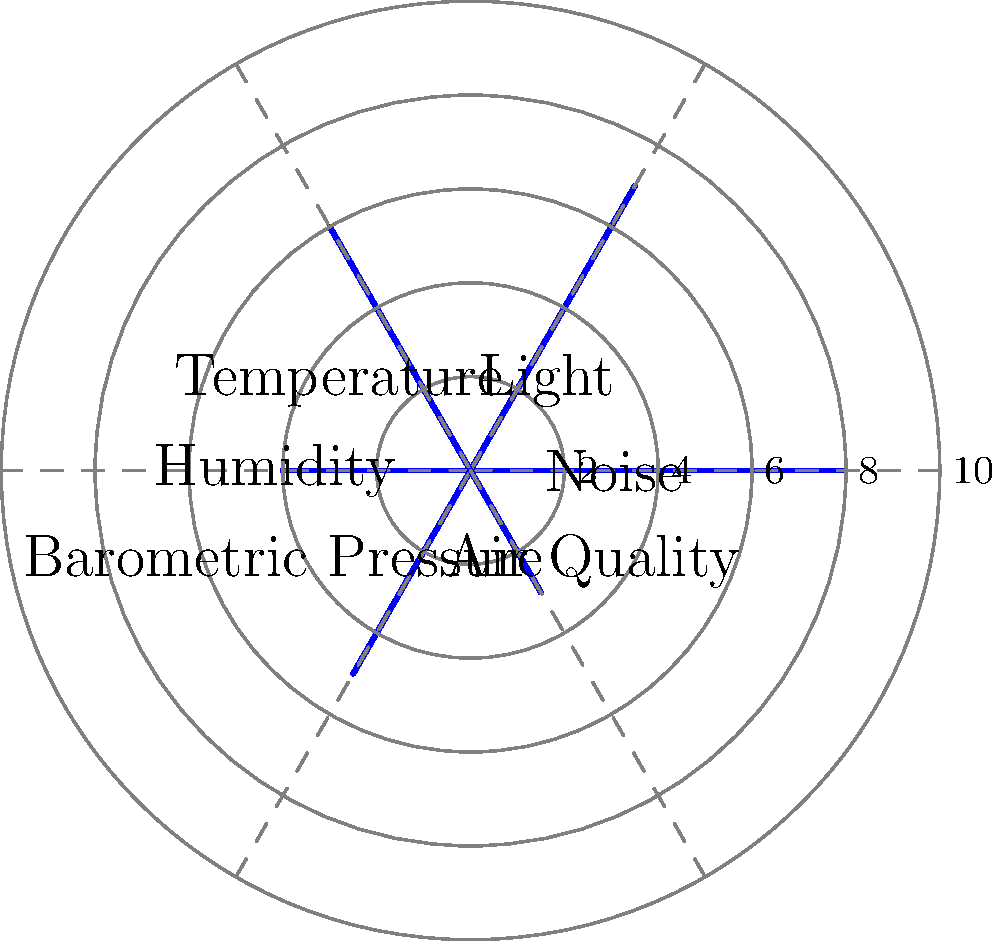Based on the multi-variable radar chart showing the influence of environmental factors on headache triggers, which factor appears to have the least impact on your daughter's headaches, and what might this suggest about potential preventive measures? To answer this question, we need to analyze the radar chart and interpret its data:

1. The chart shows six environmental factors: Noise, Light, Temperature, Humidity, Barometric Pressure, and Air Quality.
2. Each factor is rated on a scale from 0 to 10, with 10 representing the highest impact.
3. We need to identify the factor with the lowest value:
   - Noise: 8
   - Light: 7
   - Temperature: 6
   - Humidity: 4
   - Barometric Pressure: 5
   - Air Quality: 3

4. Air Quality has the lowest value at 3, indicating it has the least impact on your daughter's headaches.

5. This suggests that focusing on improving air quality may not be the most effective preventive measure for your daughter's headaches.

6. Instead, prioritizing interventions related to noise reduction (rated 8) and light management (rated 7) might be more beneficial in preventing or reducing the frequency of headaches.

7. Potential preventive measures could include:
   - Using noise-cancelling headphones or creating a quiet environment
   - Installing light-dimming curtains or adjusting screen brightness on devices

8. It's important to note that while air quality seems to have the least impact, it shouldn't be completely ignored, as it still contributes to the overall environmental factors affecting headaches.
Answer: Air Quality; focus on noise reduction and light management for prevention. 